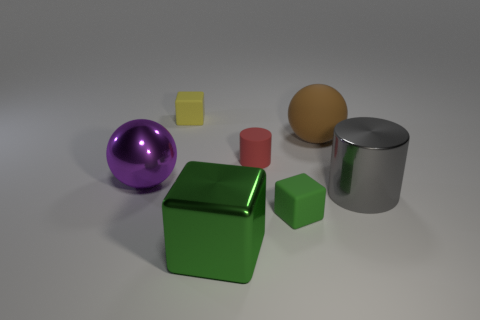Add 2 yellow metal cylinders. How many objects exist? 9 Subtract all blocks. How many objects are left? 4 Subtract all matte cubes. Subtract all small yellow things. How many objects are left? 4 Add 4 small objects. How many small objects are left? 7 Add 6 big red metal cylinders. How many big red metal cylinders exist? 6 Subtract 0 yellow spheres. How many objects are left? 7 